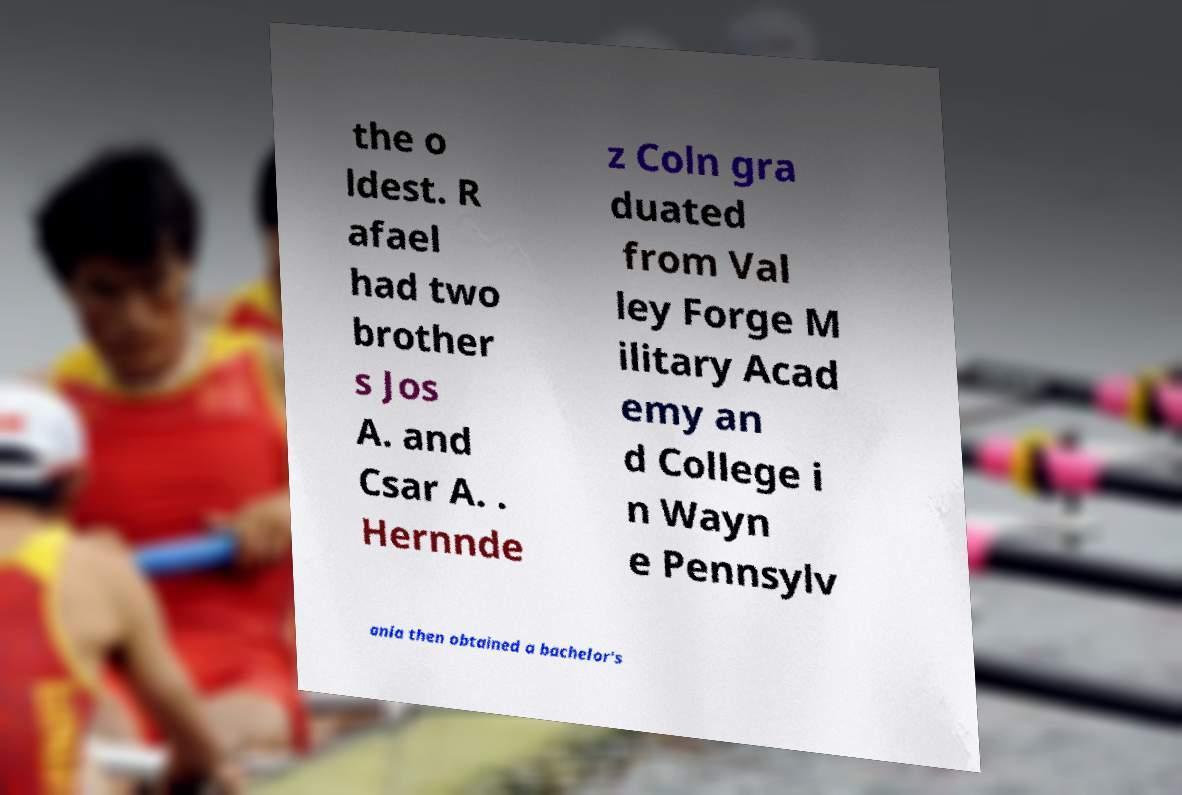Can you accurately transcribe the text from the provided image for me? the o ldest. R afael had two brother s Jos A. and Csar A. . Hernnde z Coln gra duated from Val ley Forge M ilitary Acad emy an d College i n Wayn e Pennsylv ania then obtained a bachelor's 